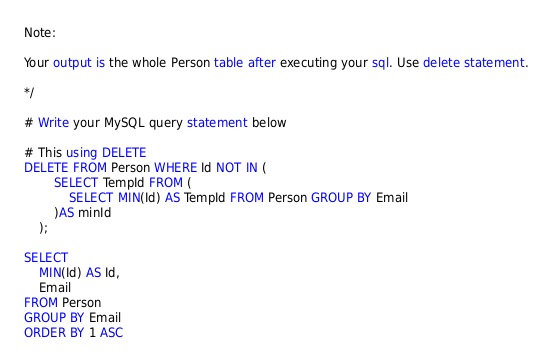<code> <loc_0><loc_0><loc_500><loc_500><_SQL_>Note:

Your output is the whole Person table after executing your sql. Use delete statement.

*/

# Write your MySQL query statement below

# This using DELETE
DELETE FROM Person WHERE Id NOT IN (
        SELECT TempId FROM (
            SELECT MIN(Id) AS TempId FROM Person GROUP BY Email
        )AS minId
    );

SELECT
    MIN(Id) AS Id,
    Email
FROM Person
GROUP BY Email
ORDER BY 1 ASC
</code> 